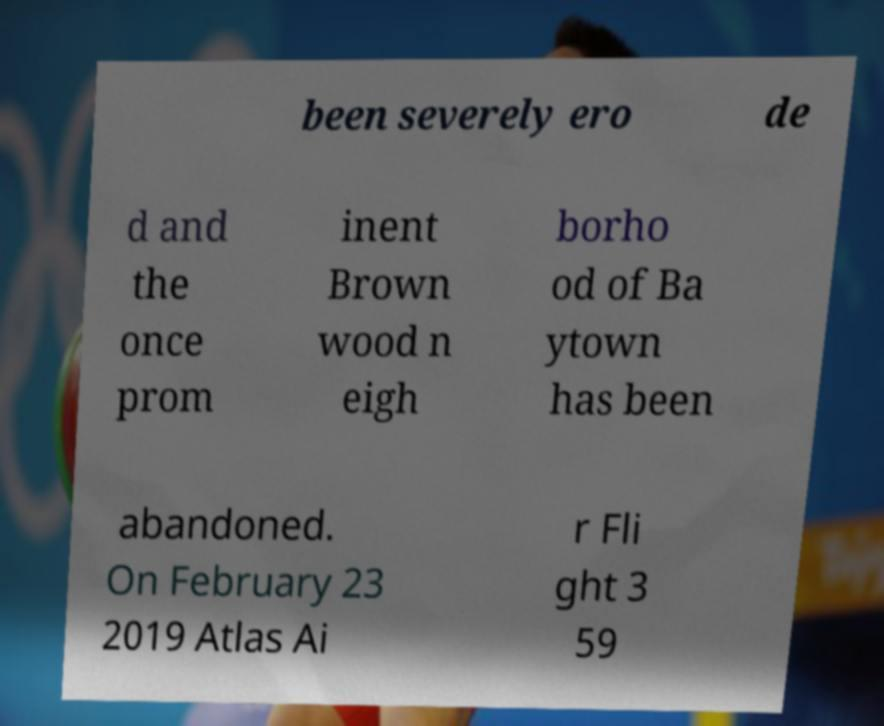For documentation purposes, I need the text within this image transcribed. Could you provide that? been severely ero de d and the once prom inent Brown wood n eigh borho od of Ba ytown has been abandoned. On February 23 2019 Atlas Ai r Fli ght 3 59 